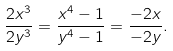Convert formula to latex. <formula><loc_0><loc_0><loc_500><loc_500>\frac { 2 x ^ { 3 } } { 2 y ^ { 3 } } = \frac { x ^ { 4 } - 1 } { y ^ { 4 } - 1 } = \frac { - 2 x } { - 2 y } .</formula> 